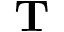<formula> <loc_0><loc_0><loc_500><loc_500>{ T }</formula> 